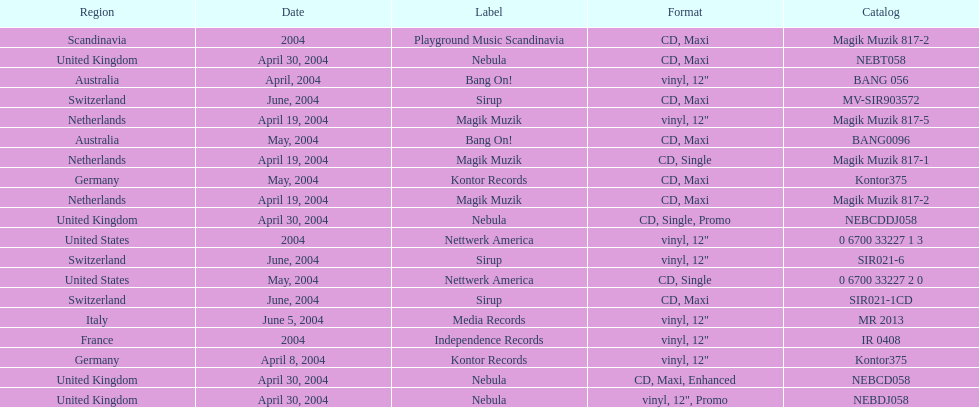What label was italy on? Media Records. 